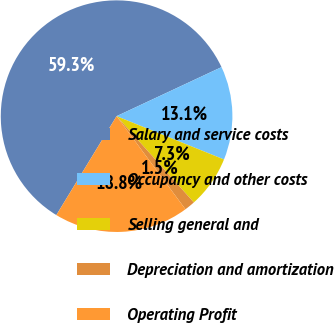Convert chart to OTSL. <chart><loc_0><loc_0><loc_500><loc_500><pie_chart><fcel>Salary and service costs<fcel>Occupancy and other costs<fcel>Selling general and<fcel>Depreciation and amortization<fcel>Operating Profit<nl><fcel>59.33%<fcel>13.06%<fcel>7.27%<fcel>1.49%<fcel>18.84%<nl></chart> 